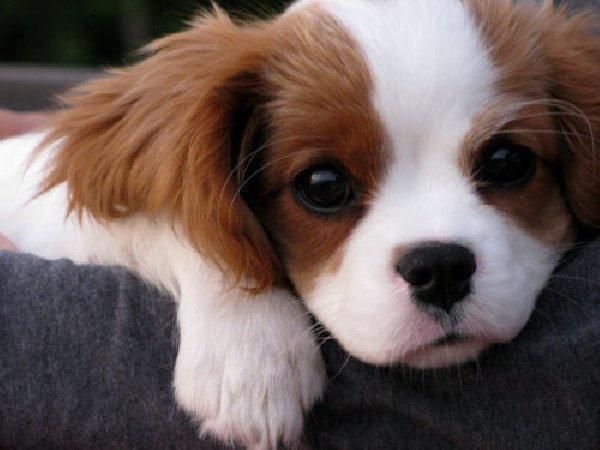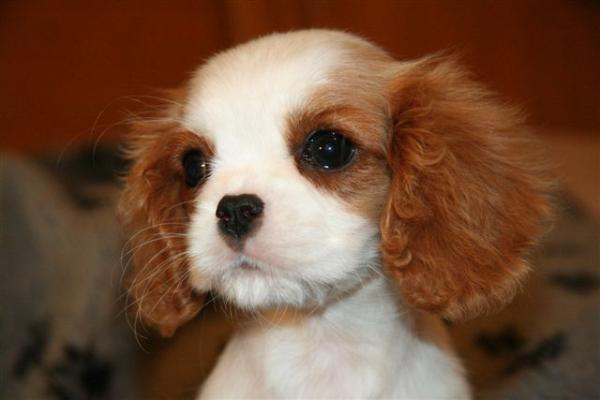The first image is the image on the left, the second image is the image on the right. Analyze the images presented: Is the assertion "Each image shows one brown and white dog on green grass." valid? Answer yes or no. No. 